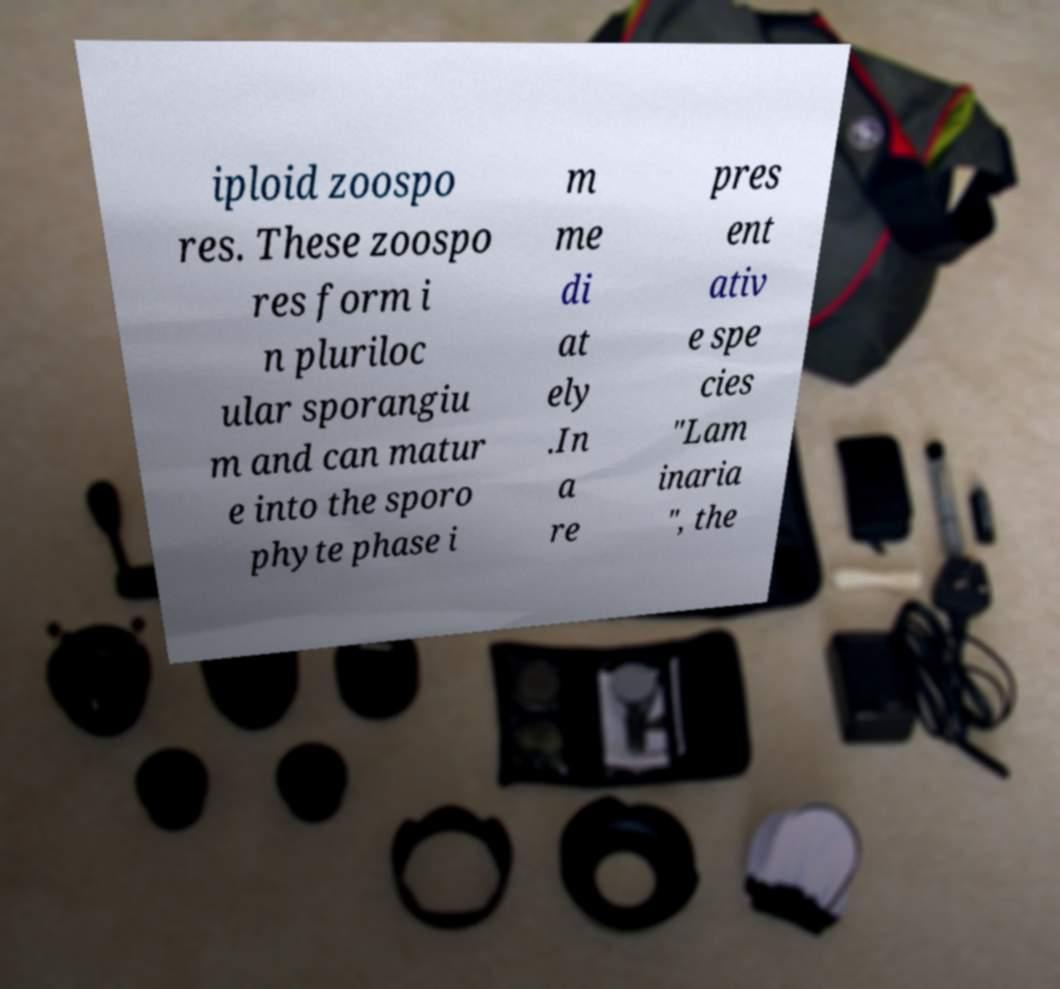Can you accurately transcribe the text from the provided image for me? iploid zoospo res. These zoospo res form i n pluriloc ular sporangiu m and can matur e into the sporo phyte phase i m me di at ely .In a re pres ent ativ e spe cies "Lam inaria ", the 